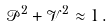Convert formula to latex. <formula><loc_0><loc_0><loc_500><loc_500>\mathcal { P } ^ { 2 } + \mathcal { V } ^ { 2 } \approx 1 \, .</formula> 